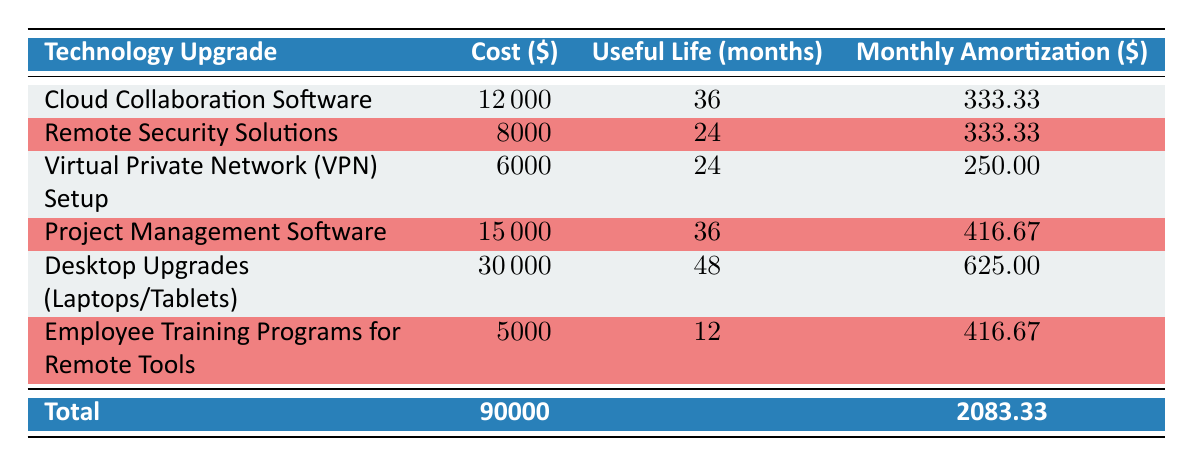What is the cost of the Cloud Collaboration Software? The table indicates that the cost listed under the "Cost ($)" column for the "Cloud Collaboration Software" row is 12000.
Answer: 12000 What is the useful life in months for Remote Security Solutions? The table shows that the useful life listed under the "Useful Life (months)" column for "Remote Security Solutions" is 24 months.
Answer: 24 Which technology upgrade has the highest monthly amortization? By comparing the "Monthly Amortization ($)" column values, "Desktop Upgrades (Laptops/Tablets)" has the highest monthly amortization at 625.00.
Answer: Desktop Upgrades (Laptops/Tablets) What is the total investment for all technology upgrades? The last row labeled "Total" in the "Cost ($)" column indicates that the total investment is 90000.
Answer: 90000 What is the average monthly amortization for the technology upgrades? To find the average, sum the monthly amortizations: 333.33 + 333.33 + 250.00 + 416.67 + 625.00 + 416.67 = 2083.00, then divide by the number of items (6): 2083.00 / 6 = 347.17.
Answer: 347.17 Is the total monthly amortization greater than the monthly amortization of Project Management Software? The total monthly amortization is 2083.33, while the amortization for "Project Management Software" is 416.67. Since 2083.33 is greater than 416.67, the answer is yes.
Answer: Yes What is the cost difference between the Desktop Upgrades and the Employee Training Programs for Remote Tools? The cost of Desktop Upgrades is 30000 and the cost of Employee Training Programs is 5000. The difference is 30000 - 5000 = 25000.
Answer: 25000 List the items that have a useful life of 24 months. Referring to the "Useful Life (months)" column, "Remote Security Solutions" and "Virtual Private Network (VPN) Setup" both have a useful life of 24 months.
Answer: Remote Security Solutions, Virtual Private Network (VPN) Setup What percentage of the total investment does the cost of Employee Training Programs represent? The cost of Employee Training Programs is 5000. To find the percentage: (5000 / 90000) * 100 = 5.56%.
Answer: 5.56% 